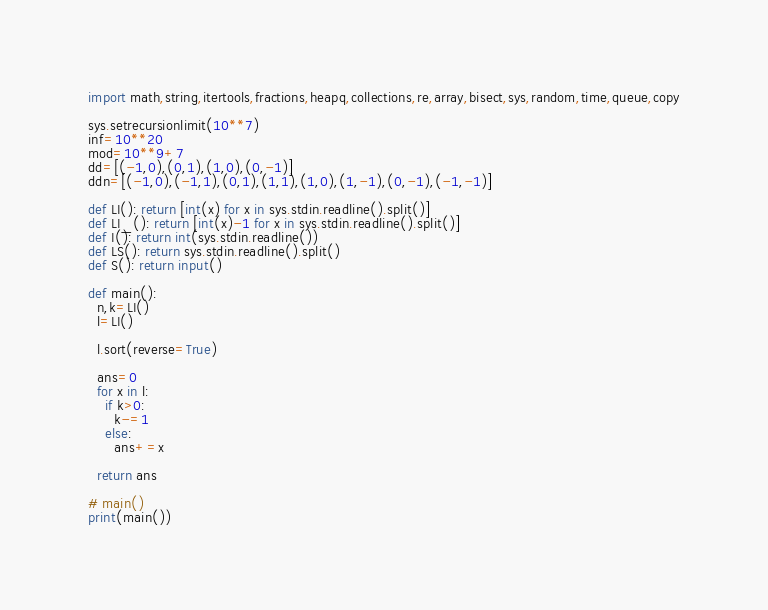<code> <loc_0><loc_0><loc_500><loc_500><_Python_>import math,string,itertools,fractions,heapq,collections,re,array,bisect,sys,random,time,queue,copy

sys.setrecursionlimit(10**7)
inf=10**20
mod=10**9+7
dd=[(-1,0),(0,1),(1,0),(0,-1)]
ddn=[(-1,0),(-1,1),(0,1),(1,1),(1,0),(1,-1),(0,-1),(-1,-1)]

def LI(): return [int(x) for x in sys.stdin.readline().split()]
def LI_(): return [int(x)-1 for x in sys.stdin.readline().split()]
def I(): return int(sys.stdin.readline())
def LS(): return sys.stdin.readline().split()
def S(): return input()

def main():
  n,k=LI()
  l=LI()

  l.sort(reverse=True)

  ans=0
  for x in l:
    if k>0:
      k-=1
    else:
      ans+=x

  return ans

# main()
print(main())
</code> 